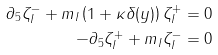Convert formula to latex. <formula><loc_0><loc_0><loc_500><loc_500>\partial _ { 5 } \zeta ^ { - } _ { I } + m _ { I } \left ( 1 + \kappa \delta ( y ) \right ) \zeta ^ { + } _ { I } & = 0 \\ - \partial _ { 5 } \zeta ^ { + } _ { I } + m _ { I } \zeta ^ { - } _ { I } & = 0</formula> 